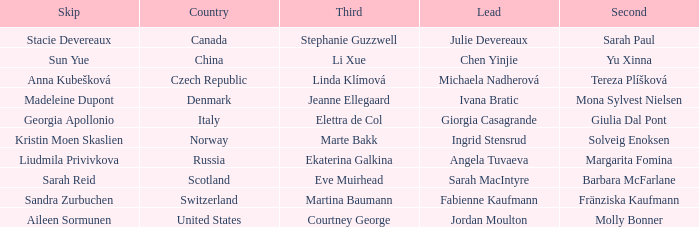What is the second that has jordan moulton as the lead? Molly Bonner. 